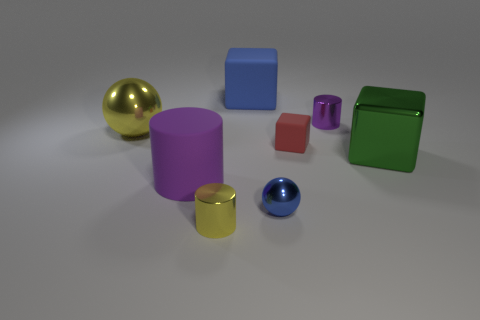Add 1 red things. How many objects exist? 9 Subtract all spheres. How many objects are left? 6 Subtract all large matte cylinders. Subtract all small yellow things. How many objects are left? 6 Add 3 small yellow cylinders. How many small yellow cylinders are left? 4 Add 6 small purple objects. How many small purple objects exist? 7 Subtract 0 red spheres. How many objects are left? 8 